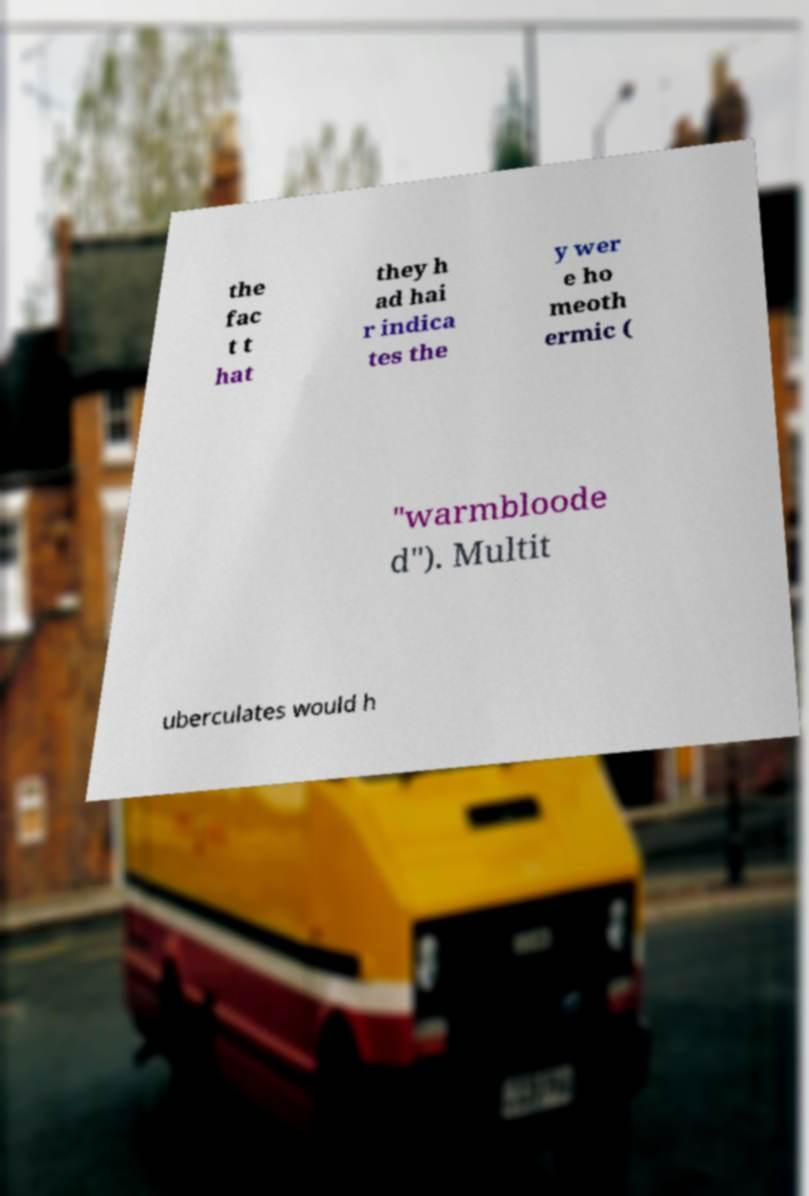Can you read and provide the text displayed in the image?This photo seems to have some interesting text. Can you extract and type it out for me? the fac t t hat they h ad hai r indica tes the y wer e ho meoth ermic ( "warmbloode d"). Multit uberculates would h 